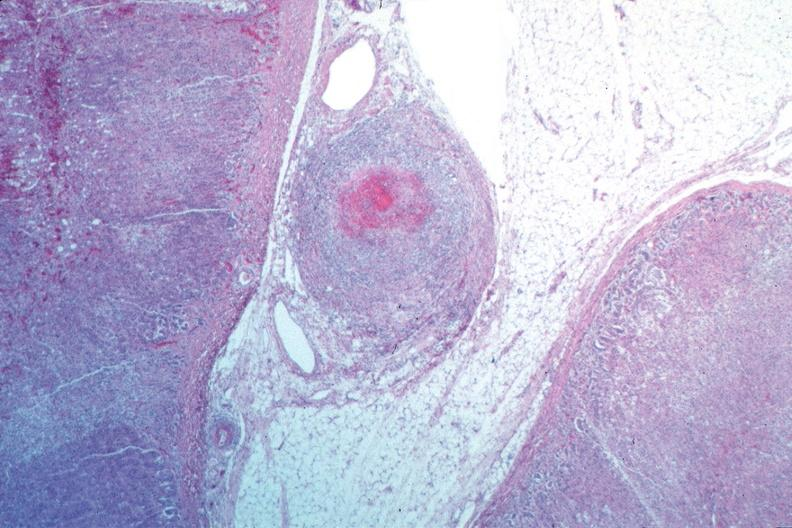does cranial artery show vasculitis, polyarteritis nodosa?
Answer the question using a single word or phrase. No 